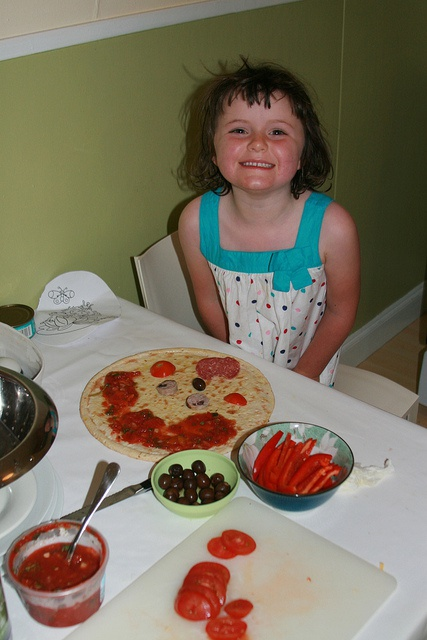Describe the objects in this image and their specific colors. I can see people in darkgray, brown, black, and teal tones, dining table in darkgray and lightgray tones, pizza in darkgray, tan, maroon, and gray tones, bowl in darkgray, maroon, and brown tones, and bowl in darkgray, maroon, and gray tones in this image. 